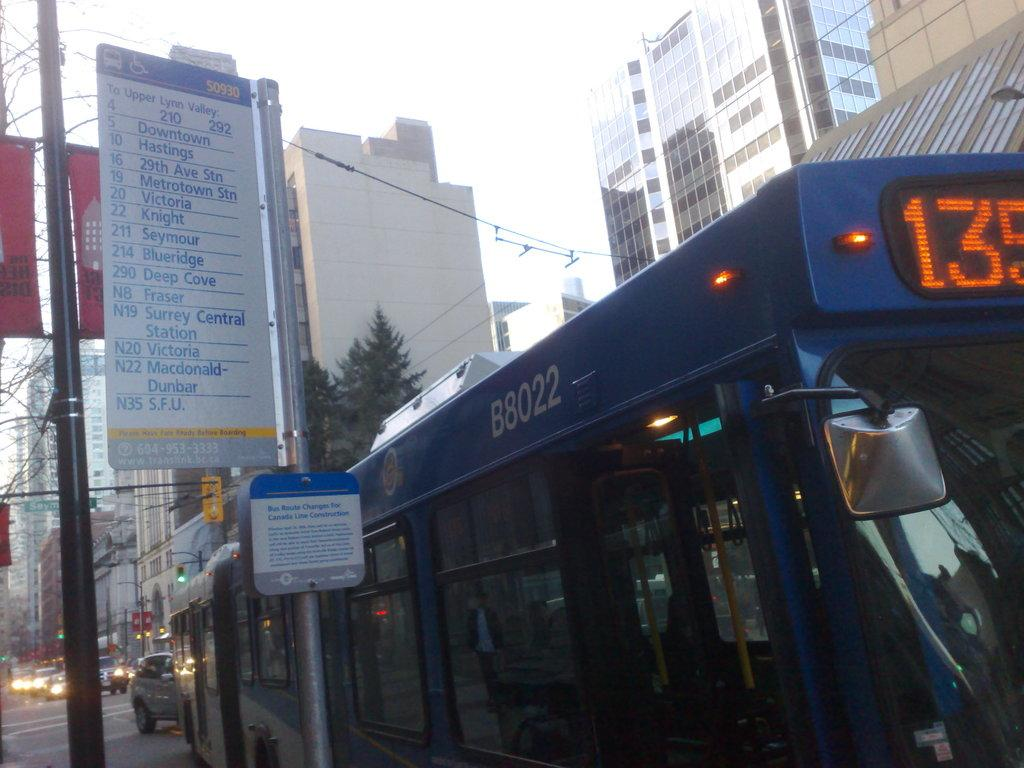<image>
Relay a brief, clear account of the picture shown. A bus is stopped at the station that is headed to Upper Lynn Valley. 